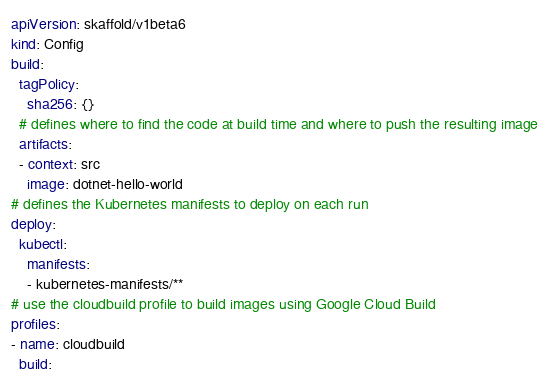Convert code to text. <code><loc_0><loc_0><loc_500><loc_500><_YAML_>apiVersion: skaffold/v1beta6
kind: Config
build:
  tagPolicy:
    sha256: {}
  # defines where to find the code at build time and where to push the resulting image
  artifacts:
  - context: src
    image: dotnet-hello-world
# defines the Kubernetes manifests to deploy on each run
deploy:
  kubectl:
    manifests:
    - kubernetes-manifests/**
# use the cloudbuild profile to build images using Google Cloud Build
profiles:
- name: cloudbuild
  build:</code> 